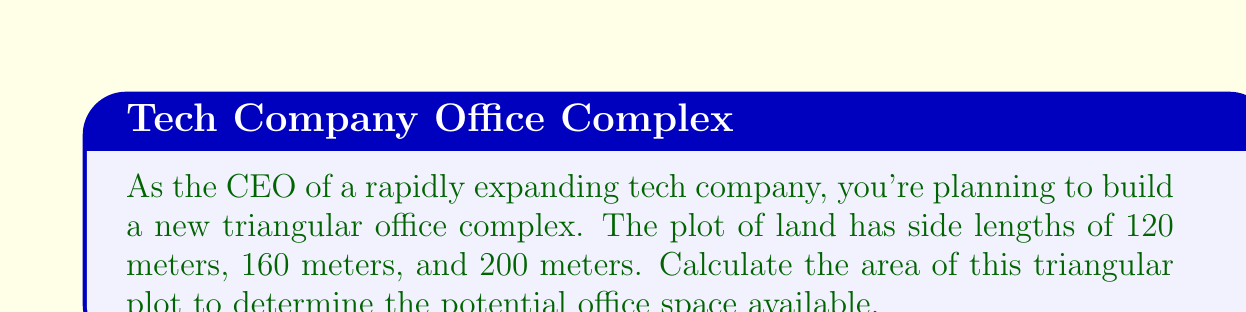Help me with this question. To solve this problem, we'll use Heron's formula for the area of a triangle given its side lengths.

Step 1: Recall Heron's formula
$$ A = \sqrt{s(s-a)(s-b)(s-c)} $$
where $A$ is the area, $s$ is the semi-perimeter, and $a$, $b$, and $c$ are the side lengths.

Step 2: Calculate the semi-perimeter $s$
$$ s = \frac{a + b + c}{2} = \frac{120 + 160 + 200}{2} = \frac{480}{2} = 240 \text{ meters} $$

Step 3: Apply Heron's formula
$$ A = \sqrt{240(240-120)(240-160)(240-200)} $$
$$ A = \sqrt{240 \cdot 120 \cdot 80 \cdot 40} $$
$$ A = \sqrt{92,160,000} $$
$$ A = 9600 \text{ square meters} $$

[asy]
unitsize(0.03cm);
pair A = (0,0), B = (160,0), C = (40,80*sqrt(3));
draw(A--B--C--cycle);
label("120m", (80,-10), S);
label("160m", (B--C)/2, NE);
label("200m", (A--C)/2, NW);
label("A", A, SW);
label("B", B, SE);
label("C", C, N);
[/asy]
Answer: 9600 square meters 